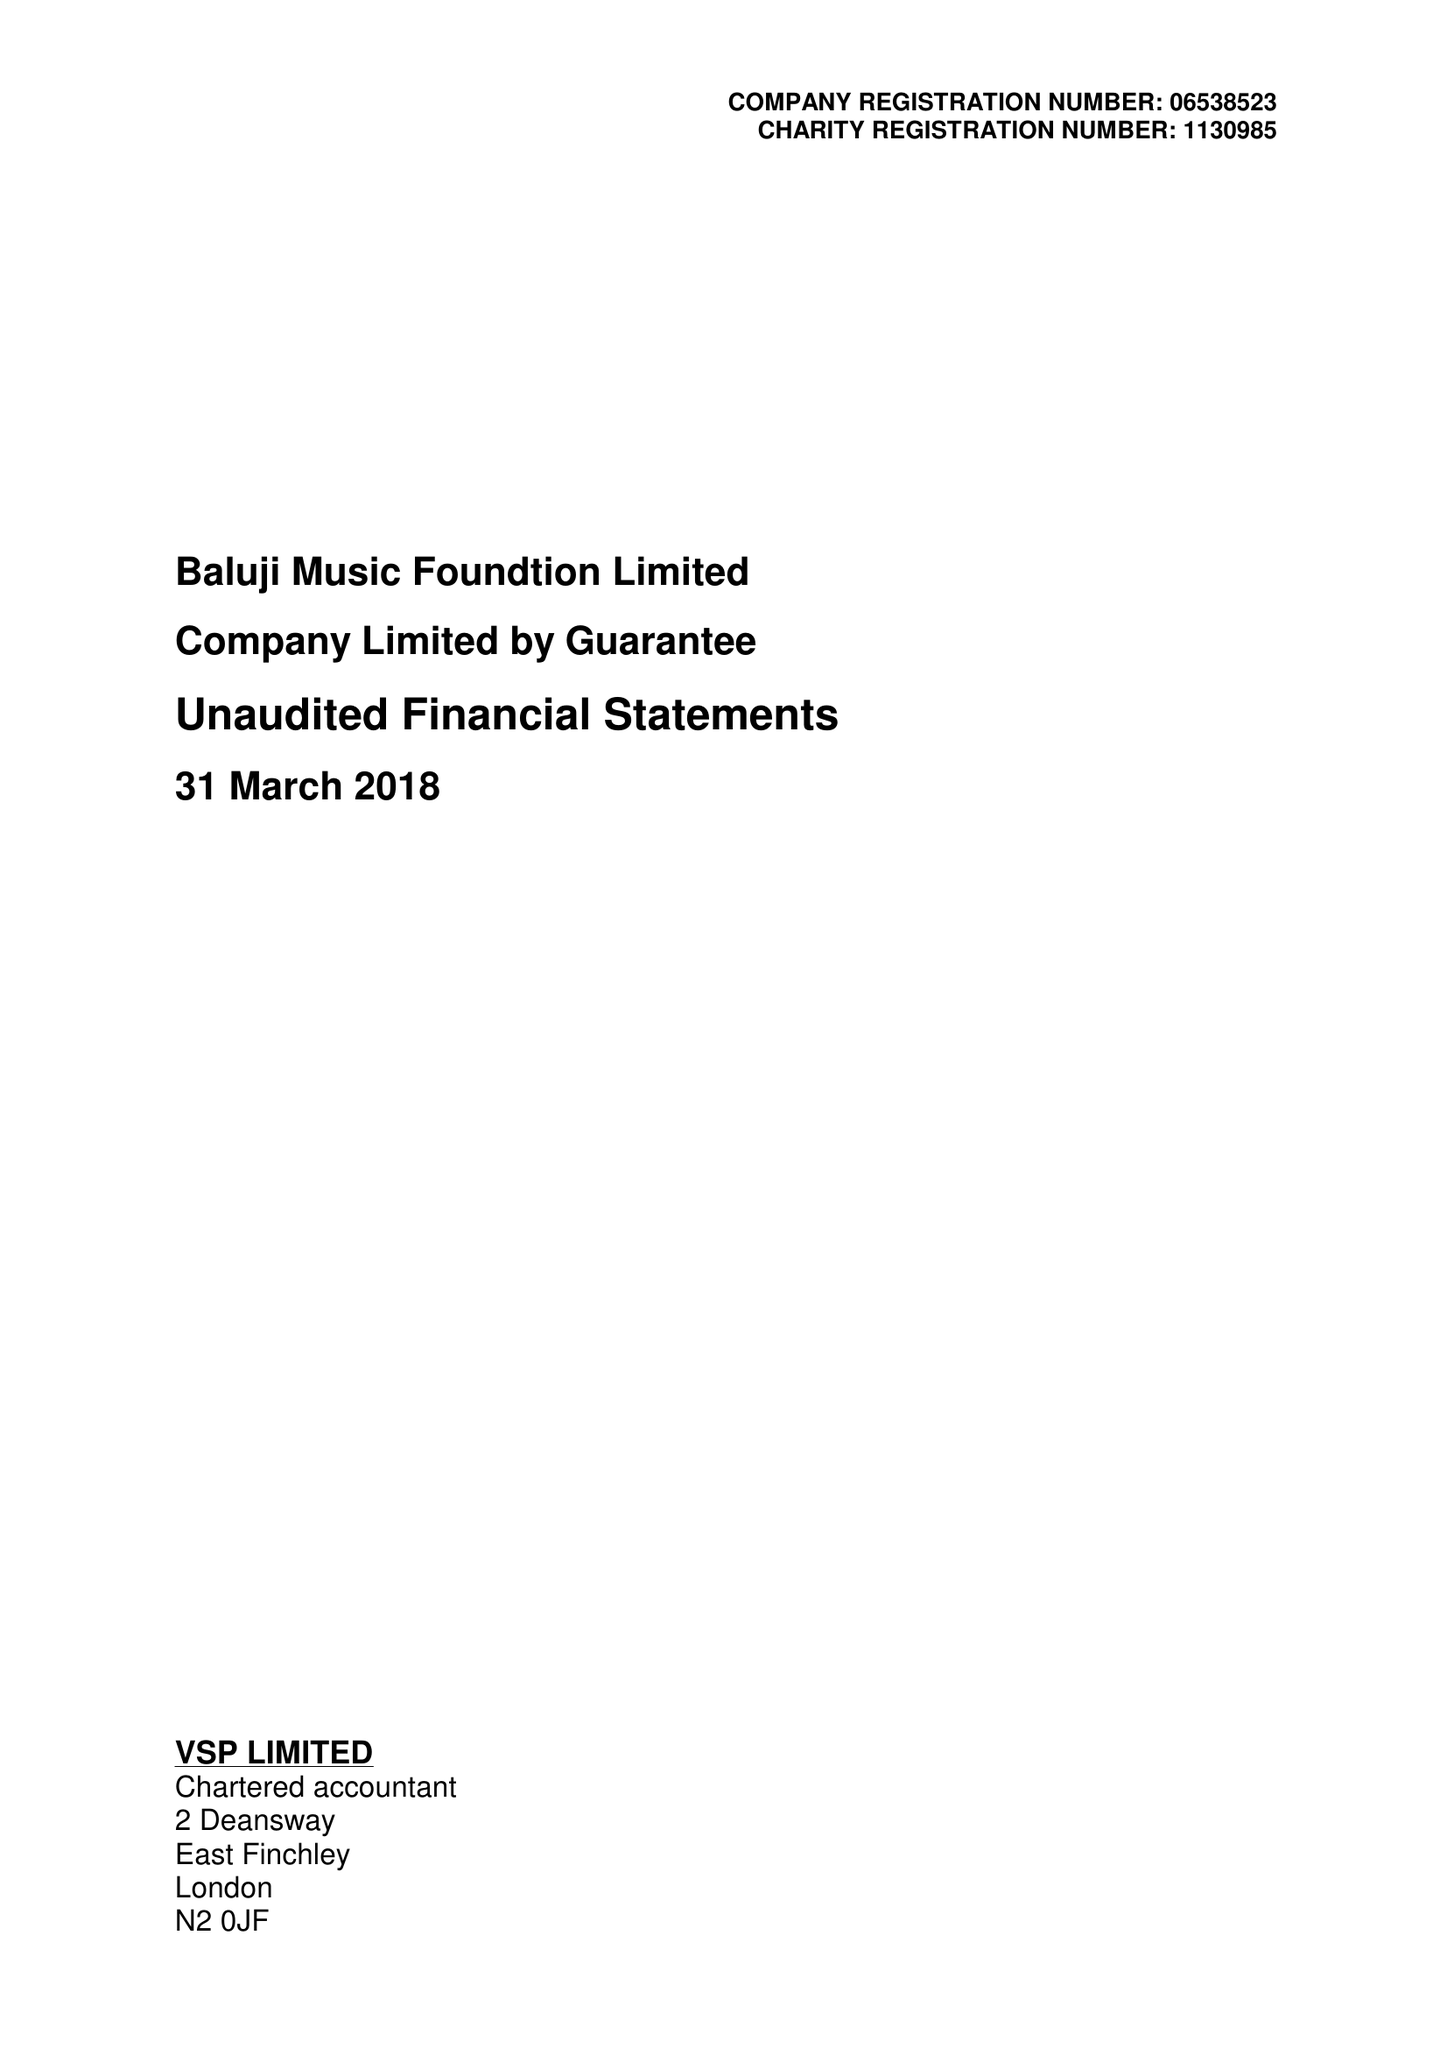What is the value for the income_annually_in_british_pounds?
Answer the question using a single word or phrase. 51344.00 